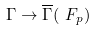<formula> <loc_0><loc_0><loc_500><loc_500>\Gamma \to \overline { \Gamma } ( \ F _ { p } )</formula> 